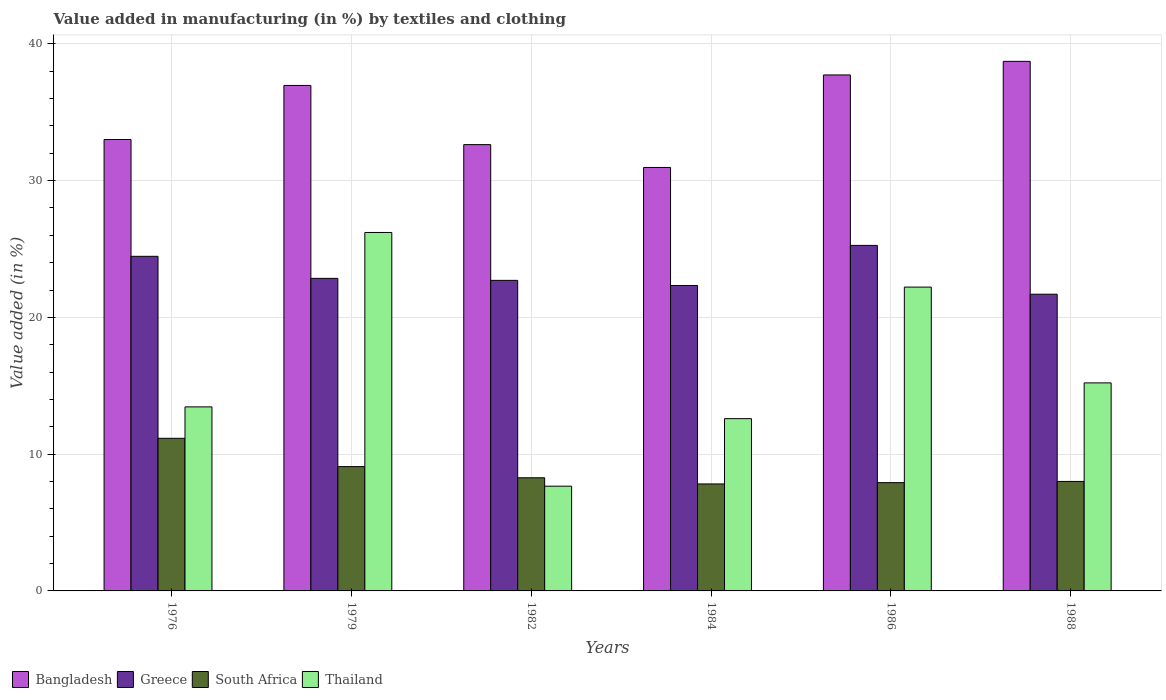How many different coloured bars are there?
Make the answer very short. 4. How many bars are there on the 6th tick from the right?
Ensure brevity in your answer.  4. What is the label of the 2nd group of bars from the left?
Offer a very short reply. 1979. What is the percentage of value added in manufacturing by textiles and clothing in South Africa in 1986?
Your answer should be compact. 7.92. Across all years, what is the maximum percentage of value added in manufacturing by textiles and clothing in Bangladesh?
Make the answer very short. 38.72. Across all years, what is the minimum percentage of value added in manufacturing by textiles and clothing in South Africa?
Make the answer very short. 7.82. In which year was the percentage of value added in manufacturing by textiles and clothing in Bangladesh maximum?
Keep it short and to the point. 1988. What is the total percentage of value added in manufacturing by textiles and clothing in Bangladesh in the graph?
Your response must be concise. 209.99. What is the difference between the percentage of value added in manufacturing by textiles and clothing in Thailand in 1984 and that in 1988?
Make the answer very short. -2.61. What is the difference between the percentage of value added in manufacturing by textiles and clothing in Bangladesh in 1986 and the percentage of value added in manufacturing by textiles and clothing in South Africa in 1984?
Offer a very short reply. 29.9. What is the average percentage of value added in manufacturing by textiles and clothing in Thailand per year?
Offer a very short reply. 16.22. In the year 1988, what is the difference between the percentage of value added in manufacturing by textiles and clothing in Bangladesh and percentage of value added in manufacturing by textiles and clothing in Greece?
Give a very brief answer. 17.02. In how many years, is the percentage of value added in manufacturing by textiles and clothing in Thailand greater than 36 %?
Make the answer very short. 0. What is the ratio of the percentage of value added in manufacturing by textiles and clothing in South Africa in 1986 to that in 1988?
Provide a short and direct response. 0.99. Is the percentage of value added in manufacturing by textiles and clothing in Bangladesh in 1982 less than that in 1986?
Offer a very short reply. Yes. What is the difference between the highest and the second highest percentage of value added in manufacturing by textiles and clothing in Greece?
Your answer should be compact. 0.8. What is the difference between the highest and the lowest percentage of value added in manufacturing by textiles and clothing in Greece?
Your response must be concise. 3.57. What does the 4th bar from the left in 1979 represents?
Keep it short and to the point. Thailand. What does the 2nd bar from the right in 1982 represents?
Your answer should be very brief. South Africa. Is it the case that in every year, the sum of the percentage of value added in manufacturing by textiles and clothing in Thailand and percentage of value added in manufacturing by textiles and clothing in Greece is greater than the percentage of value added in manufacturing by textiles and clothing in Bangladesh?
Provide a short and direct response. No. How many bars are there?
Ensure brevity in your answer.  24. What is the difference between two consecutive major ticks on the Y-axis?
Offer a terse response. 10. Are the values on the major ticks of Y-axis written in scientific E-notation?
Your answer should be very brief. No. Does the graph contain grids?
Your answer should be compact. Yes. Where does the legend appear in the graph?
Provide a succinct answer. Bottom left. How are the legend labels stacked?
Give a very brief answer. Horizontal. What is the title of the graph?
Provide a succinct answer. Value added in manufacturing (in %) by textiles and clothing. Does "Yemen, Rep." appear as one of the legend labels in the graph?
Your answer should be very brief. No. What is the label or title of the Y-axis?
Your answer should be compact. Value added (in %). What is the Value added (in %) in Bangladesh in 1976?
Provide a short and direct response. 33. What is the Value added (in %) of Greece in 1976?
Offer a terse response. 24.46. What is the Value added (in %) of South Africa in 1976?
Provide a succinct answer. 11.16. What is the Value added (in %) in Thailand in 1976?
Give a very brief answer. 13.46. What is the Value added (in %) of Bangladesh in 1979?
Keep it short and to the point. 36.96. What is the Value added (in %) of Greece in 1979?
Offer a very short reply. 22.85. What is the Value added (in %) of South Africa in 1979?
Ensure brevity in your answer.  9.09. What is the Value added (in %) in Thailand in 1979?
Offer a very short reply. 26.21. What is the Value added (in %) of Bangladesh in 1982?
Keep it short and to the point. 32.63. What is the Value added (in %) of Greece in 1982?
Provide a short and direct response. 22.71. What is the Value added (in %) in South Africa in 1982?
Provide a succinct answer. 8.27. What is the Value added (in %) of Thailand in 1982?
Provide a short and direct response. 7.66. What is the Value added (in %) of Bangladesh in 1984?
Offer a terse response. 30.96. What is the Value added (in %) of Greece in 1984?
Provide a short and direct response. 22.33. What is the Value added (in %) in South Africa in 1984?
Ensure brevity in your answer.  7.82. What is the Value added (in %) in Thailand in 1984?
Give a very brief answer. 12.6. What is the Value added (in %) of Bangladesh in 1986?
Provide a succinct answer. 37.72. What is the Value added (in %) of Greece in 1986?
Ensure brevity in your answer.  25.26. What is the Value added (in %) of South Africa in 1986?
Your response must be concise. 7.92. What is the Value added (in %) of Thailand in 1986?
Your response must be concise. 22.21. What is the Value added (in %) of Bangladesh in 1988?
Provide a short and direct response. 38.72. What is the Value added (in %) in Greece in 1988?
Ensure brevity in your answer.  21.69. What is the Value added (in %) in South Africa in 1988?
Provide a succinct answer. 8.01. What is the Value added (in %) in Thailand in 1988?
Give a very brief answer. 15.21. Across all years, what is the maximum Value added (in %) in Bangladesh?
Your response must be concise. 38.72. Across all years, what is the maximum Value added (in %) of Greece?
Your answer should be compact. 25.26. Across all years, what is the maximum Value added (in %) of South Africa?
Provide a succinct answer. 11.16. Across all years, what is the maximum Value added (in %) in Thailand?
Make the answer very short. 26.21. Across all years, what is the minimum Value added (in %) in Bangladesh?
Provide a short and direct response. 30.96. Across all years, what is the minimum Value added (in %) in Greece?
Offer a terse response. 21.69. Across all years, what is the minimum Value added (in %) of South Africa?
Make the answer very short. 7.82. Across all years, what is the minimum Value added (in %) of Thailand?
Your answer should be compact. 7.66. What is the total Value added (in %) of Bangladesh in the graph?
Offer a very short reply. 209.99. What is the total Value added (in %) in Greece in the graph?
Make the answer very short. 139.31. What is the total Value added (in %) in South Africa in the graph?
Your answer should be compact. 52.26. What is the total Value added (in %) of Thailand in the graph?
Offer a very short reply. 97.34. What is the difference between the Value added (in %) of Bangladesh in 1976 and that in 1979?
Ensure brevity in your answer.  -3.95. What is the difference between the Value added (in %) of Greece in 1976 and that in 1979?
Keep it short and to the point. 1.61. What is the difference between the Value added (in %) in South Africa in 1976 and that in 1979?
Ensure brevity in your answer.  2.07. What is the difference between the Value added (in %) in Thailand in 1976 and that in 1979?
Offer a terse response. -12.75. What is the difference between the Value added (in %) of Bangladesh in 1976 and that in 1982?
Your answer should be compact. 0.37. What is the difference between the Value added (in %) in Greece in 1976 and that in 1982?
Offer a very short reply. 1.76. What is the difference between the Value added (in %) in South Africa in 1976 and that in 1982?
Your answer should be very brief. 2.89. What is the difference between the Value added (in %) of Thailand in 1976 and that in 1982?
Provide a succinct answer. 5.8. What is the difference between the Value added (in %) in Bangladesh in 1976 and that in 1984?
Give a very brief answer. 2.04. What is the difference between the Value added (in %) of Greece in 1976 and that in 1984?
Your answer should be compact. 2.13. What is the difference between the Value added (in %) of South Africa in 1976 and that in 1984?
Give a very brief answer. 3.34. What is the difference between the Value added (in %) of Thailand in 1976 and that in 1984?
Offer a terse response. 0.86. What is the difference between the Value added (in %) in Bangladesh in 1976 and that in 1986?
Give a very brief answer. -4.72. What is the difference between the Value added (in %) in Greece in 1976 and that in 1986?
Provide a short and direct response. -0.8. What is the difference between the Value added (in %) of South Africa in 1976 and that in 1986?
Offer a very short reply. 3.24. What is the difference between the Value added (in %) in Thailand in 1976 and that in 1986?
Offer a terse response. -8.76. What is the difference between the Value added (in %) in Bangladesh in 1976 and that in 1988?
Your response must be concise. -5.71. What is the difference between the Value added (in %) of Greece in 1976 and that in 1988?
Give a very brief answer. 2.77. What is the difference between the Value added (in %) in South Africa in 1976 and that in 1988?
Ensure brevity in your answer.  3.15. What is the difference between the Value added (in %) of Thailand in 1976 and that in 1988?
Provide a succinct answer. -1.75. What is the difference between the Value added (in %) of Bangladesh in 1979 and that in 1982?
Your answer should be compact. 4.33. What is the difference between the Value added (in %) in Greece in 1979 and that in 1982?
Your answer should be very brief. 0.15. What is the difference between the Value added (in %) of South Africa in 1979 and that in 1982?
Your answer should be compact. 0.82. What is the difference between the Value added (in %) in Thailand in 1979 and that in 1982?
Keep it short and to the point. 18.55. What is the difference between the Value added (in %) of Bangladesh in 1979 and that in 1984?
Keep it short and to the point. 6. What is the difference between the Value added (in %) in Greece in 1979 and that in 1984?
Your answer should be compact. 0.52. What is the difference between the Value added (in %) of South Africa in 1979 and that in 1984?
Offer a very short reply. 1.27. What is the difference between the Value added (in %) in Thailand in 1979 and that in 1984?
Ensure brevity in your answer.  13.61. What is the difference between the Value added (in %) in Bangladesh in 1979 and that in 1986?
Provide a succinct answer. -0.77. What is the difference between the Value added (in %) in Greece in 1979 and that in 1986?
Keep it short and to the point. -2.41. What is the difference between the Value added (in %) in South Africa in 1979 and that in 1986?
Offer a terse response. 1.17. What is the difference between the Value added (in %) of Thailand in 1979 and that in 1986?
Ensure brevity in your answer.  3.99. What is the difference between the Value added (in %) in Bangladesh in 1979 and that in 1988?
Offer a very short reply. -1.76. What is the difference between the Value added (in %) of Greece in 1979 and that in 1988?
Your answer should be very brief. 1.16. What is the difference between the Value added (in %) in South Africa in 1979 and that in 1988?
Your response must be concise. 1.08. What is the difference between the Value added (in %) of Thailand in 1979 and that in 1988?
Offer a terse response. 11. What is the difference between the Value added (in %) of Bangladesh in 1982 and that in 1984?
Give a very brief answer. 1.67. What is the difference between the Value added (in %) of Greece in 1982 and that in 1984?
Your answer should be very brief. 0.37. What is the difference between the Value added (in %) in South Africa in 1982 and that in 1984?
Give a very brief answer. 0.45. What is the difference between the Value added (in %) in Thailand in 1982 and that in 1984?
Your answer should be very brief. -4.94. What is the difference between the Value added (in %) in Bangladesh in 1982 and that in 1986?
Give a very brief answer. -5.09. What is the difference between the Value added (in %) of Greece in 1982 and that in 1986?
Provide a short and direct response. -2.56. What is the difference between the Value added (in %) in South Africa in 1982 and that in 1986?
Your answer should be very brief. 0.36. What is the difference between the Value added (in %) in Thailand in 1982 and that in 1986?
Make the answer very short. -14.56. What is the difference between the Value added (in %) of Bangladesh in 1982 and that in 1988?
Offer a terse response. -6.09. What is the difference between the Value added (in %) of Greece in 1982 and that in 1988?
Give a very brief answer. 1.01. What is the difference between the Value added (in %) of South Africa in 1982 and that in 1988?
Your response must be concise. 0.27. What is the difference between the Value added (in %) in Thailand in 1982 and that in 1988?
Your answer should be very brief. -7.55. What is the difference between the Value added (in %) of Bangladesh in 1984 and that in 1986?
Offer a terse response. -6.76. What is the difference between the Value added (in %) of Greece in 1984 and that in 1986?
Offer a terse response. -2.93. What is the difference between the Value added (in %) of South Africa in 1984 and that in 1986?
Keep it short and to the point. -0.09. What is the difference between the Value added (in %) in Thailand in 1984 and that in 1986?
Offer a terse response. -9.62. What is the difference between the Value added (in %) in Bangladesh in 1984 and that in 1988?
Keep it short and to the point. -7.76. What is the difference between the Value added (in %) in Greece in 1984 and that in 1988?
Your answer should be very brief. 0.64. What is the difference between the Value added (in %) in South Africa in 1984 and that in 1988?
Provide a succinct answer. -0.18. What is the difference between the Value added (in %) of Thailand in 1984 and that in 1988?
Your response must be concise. -2.61. What is the difference between the Value added (in %) in Bangladesh in 1986 and that in 1988?
Your response must be concise. -0.99. What is the difference between the Value added (in %) in Greece in 1986 and that in 1988?
Provide a succinct answer. 3.57. What is the difference between the Value added (in %) of South Africa in 1986 and that in 1988?
Your answer should be very brief. -0.09. What is the difference between the Value added (in %) of Thailand in 1986 and that in 1988?
Your response must be concise. 7. What is the difference between the Value added (in %) in Bangladesh in 1976 and the Value added (in %) in Greece in 1979?
Give a very brief answer. 10.15. What is the difference between the Value added (in %) in Bangladesh in 1976 and the Value added (in %) in South Africa in 1979?
Your answer should be compact. 23.91. What is the difference between the Value added (in %) in Bangladesh in 1976 and the Value added (in %) in Thailand in 1979?
Keep it short and to the point. 6.8. What is the difference between the Value added (in %) of Greece in 1976 and the Value added (in %) of South Africa in 1979?
Your answer should be compact. 15.38. What is the difference between the Value added (in %) in Greece in 1976 and the Value added (in %) in Thailand in 1979?
Provide a short and direct response. -1.74. What is the difference between the Value added (in %) in South Africa in 1976 and the Value added (in %) in Thailand in 1979?
Ensure brevity in your answer.  -15.05. What is the difference between the Value added (in %) in Bangladesh in 1976 and the Value added (in %) in Greece in 1982?
Make the answer very short. 10.3. What is the difference between the Value added (in %) in Bangladesh in 1976 and the Value added (in %) in South Africa in 1982?
Provide a short and direct response. 24.73. What is the difference between the Value added (in %) of Bangladesh in 1976 and the Value added (in %) of Thailand in 1982?
Your answer should be very brief. 25.35. What is the difference between the Value added (in %) in Greece in 1976 and the Value added (in %) in South Africa in 1982?
Offer a terse response. 16.19. What is the difference between the Value added (in %) of Greece in 1976 and the Value added (in %) of Thailand in 1982?
Your response must be concise. 16.81. What is the difference between the Value added (in %) in South Africa in 1976 and the Value added (in %) in Thailand in 1982?
Offer a very short reply. 3.5. What is the difference between the Value added (in %) in Bangladesh in 1976 and the Value added (in %) in Greece in 1984?
Make the answer very short. 10.67. What is the difference between the Value added (in %) in Bangladesh in 1976 and the Value added (in %) in South Africa in 1984?
Your answer should be very brief. 25.18. What is the difference between the Value added (in %) of Bangladesh in 1976 and the Value added (in %) of Thailand in 1984?
Keep it short and to the point. 20.41. What is the difference between the Value added (in %) in Greece in 1976 and the Value added (in %) in South Africa in 1984?
Provide a succinct answer. 16.64. What is the difference between the Value added (in %) in Greece in 1976 and the Value added (in %) in Thailand in 1984?
Offer a very short reply. 11.87. What is the difference between the Value added (in %) of South Africa in 1976 and the Value added (in %) of Thailand in 1984?
Offer a terse response. -1.44. What is the difference between the Value added (in %) of Bangladesh in 1976 and the Value added (in %) of Greece in 1986?
Ensure brevity in your answer.  7.74. What is the difference between the Value added (in %) of Bangladesh in 1976 and the Value added (in %) of South Africa in 1986?
Give a very brief answer. 25.09. What is the difference between the Value added (in %) of Bangladesh in 1976 and the Value added (in %) of Thailand in 1986?
Your response must be concise. 10.79. What is the difference between the Value added (in %) in Greece in 1976 and the Value added (in %) in South Africa in 1986?
Keep it short and to the point. 16.55. What is the difference between the Value added (in %) of Greece in 1976 and the Value added (in %) of Thailand in 1986?
Make the answer very short. 2.25. What is the difference between the Value added (in %) in South Africa in 1976 and the Value added (in %) in Thailand in 1986?
Make the answer very short. -11.05. What is the difference between the Value added (in %) in Bangladesh in 1976 and the Value added (in %) in Greece in 1988?
Provide a succinct answer. 11.31. What is the difference between the Value added (in %) of Bangladesh in 1976 and the Value added (in %) of South Africa in 1988?
Offer a terse response. 25. What is the difference between the Value added (in %) in Bangladesh in 1976 and the Value added (in %) in Thailand in 1988?
Provide a short and direct response. 17.79. What is the difference between the Value added (in %) of Greece in 1976 and the Value added (in %) of South Africa in 1988?
Offer a very short reply. 16.46. What is the difference between the Value added (in %) of Greece in 1976 and the Value added (in %) of Thailand in 1988?
Provide a short and direct response. 9.25. What is the difference between the Value added (in %) of South Africa in 1976 and the Value added (in %) of Thailand in 1988?
Offer a terse response. -4.05. What is the difference between the Value added (in %) of Bangladesh in 1979 and the Value added (in %) of Greece in 1982?
Make the answer very short. 14.25. What is the difference between the Value added (in %) of Bangladesh in 1979 and the Value added (in %) of South Africa in 1982?
Your answer should be very brief. 28.68. What is the difference between the Value added (in %) in Bangladesh in 1979 and the Value added (in %) in Thailand in 1982?
Offer a very short reply. 29.3. What is the difference between the Value added (in %) in Greece in 1979 and the Value added (in %) in South Africa in 1982?
Offer a terse response. 14.58. What is the difference between the Value added (in %) in Greece in 1979 and the Value added (in %) in Thailand in 1982?
Ensure brevity in your answer.  15.19. What is the difference between the Value added (in %) of South Africa in 1979 and the Value added (in %) of Thailand in 1982?
Provide a short and direct response. 1.43. What is the difference between the Value added (in %) of Bangladesh in 1979 and the Value added (in %) of Greece in 1984?
Give a very brief answer. 14.62. What is the difference between the Value added (in %) of Bangladesh in 1979 and the Value added (in %) of South Africa in 1984?
Keep it short and to the point. 29.13. What is the difference between the Value added (in %) in Bangladesh in 1979 and the Value added (in %) in Thailand in 1984?
Provide a succinct answer. 24.36. What is the difference between the Value added (in %) of Greece in 1979 and the Value added (in %) of South Africa in 1984?
Your answer should be very brief. 15.03. What is the difference between the Value added (in %) of Greece in 1979 and the Value added (in %) of Thailand in 1984?
Offer a terse response. 10.26. What is the difference between the Value added (in %) in South Africa in 1979 and the Value added (in %) in Thailand in 1984?
Keep it short and to the point. -3.51. What is the difference between the Value added (in %) in Bangladesh in 1979 and the Value added (in %) in Greece in 1986?
Offer a terse response. 11.69. What is the difference between the Value added (in %) of Bangladesh in 1979 and the Value added (in %) of South Africa in 1986?
Your response must be concise. 29.04. What is the difference between the Value added (in %) of Bangladesh in 1979 and the Value added (in %) of Thailand in 1986?
Offer a terse response. 14.74. What is the difference between the Value added (in %) of Greece in 1979 and the Value added (in %) of South Africa in 1986?
Your answer should be very brief. 14.94. What is the difference between the Value added (in %) in Greece in 1979 and the Value added (in %) in Thailand in 1986?
Provide a succinct answer. 0.64. What is the difference between the Value added (in %) in South Africa in 1979 and the Value added (in %) in Thailand in 1986?
Your answer should be compact. -13.12. What is the difference between the Value added (in %) in Bangladesh in 1979 and the Value added (in %) in Greece in 1988?
Your response must be concise. 15.26. What is the difference between the Value added (in %) in Bangladesh in 1979 and the Value added (in %) in South Africa in 1988?
Ensure brevity in your answer.  28.95. What is the difference between the Value added (in %) of Bangladesh in 1979 and the Value added (in %) of Thailand in 1988?
Give a very brief answer. 21.75. What is the difference between the Value added (in %) in Greece in 1979 and the Value added (in %) in South Africa in 1988?
Your response must be concise. 14.85. What is the difference between the Value added (in %) in Greece in 1979 and the Value added (in %) in Thailand in 1988?
Offer a very short reply. 7.64. What is the difference between the Value added (in %) of South Africa in 1979 and the Value added (in %) of Thailand in 1988?
Your response must be concise. -6.12. What is the difference between the Value added (in %) of Bangladesh in 1982 and the Value added (in %) of Greece in 1984?
Keep it short and to the point. 10.3. What is the difference between the Value added (in %) in Bangladesh in 1982 and the Value added (in %) in South Africa in 1984?
Provide a short and direct response. 24.81. What is the difference between the Value added (in %) in Bangladesh in 1982 and the Value added (in %) in Thailand in 1984?
Offer a terse response. 20.03. What is the difference between the Value added (in %) in Greece in 1982 and the Value added (in %) in South Africa in 1984?
Provide a short and direct response. 14.88. What is the difference between the Value added (in %) in Greece in 1982 and the Value added (in %) in Thailand in 1984?
Offer a very short reply. 10.11. What is the difference between the Value added (in %) of South Africa in 1982 and the Value added (in %) of Thailand in 1984?
Provide a succinct answer. -4.32. What is the difference between the Value added (in %) of Bangladesh in 1982 and the Value added (in %) of Greece in 1986?
Make the answer very short. 7.37. What is the difference between the Value added (in %) in Bangladesh in 1982 and the Value added (in %) in South Africa in 1986?
Provide a succinct answer. 24.71. What is the difference between the Value added (in %) of Bangladesh in 1982 and the Value added (in %) of Thailand in 1986?
Give a very brief answer. 10.42. What is the difference between the Value added (in %) of Greece in 1982 and the Value added (in %) of South Africa in 1986?
Provide a short and direct response. 14.79. What is the difference between the Value added (in %) in Greece in 1982 and the Value added (in %) in Thailand in 1986?
Provide a succinct answer. 0.49. What is the difference between the Value added (in %) of South Africa in 1982 and the Value added (in %) of Thailand in 1986?
Your answer should be very brief. -13.94. What is the difference between the Value added (in %) of Bangladesh in 1982 and the Value added (in %) of Greece in 1988?
Offer a very short reply. 10.94. What is the difference between the Value added (in %) of Bangladesh in 1982 and the Value added (in %) of South Africa in 1988?
Offer a terse response. 24.63. What is the difference between the Value added (in %) in Bangladesh in 1982 and the Value added (in %) in Thailand in 1988?
Provide a succinct answer. 17.42. What is the difference between the Value added (in %) of Greece in 1982 and the Value added (in %) of South Africa in 1988?
Provide a succinct answer. 14.7. What is the difference between the Value added (in %) in Greece in 1982 and the Value added (in %) in Thailand in 1988?
Ensure brevity in your answer.  7.5. What is the difference between the Value added (in %) in South Africa in 1982 and the Value added (in %) in Thailand in 1988?
Ensure brevity in your answer.  -6.94. What is the difference between the Value added (in %) in Bangladesh in 1984 and the Value added (in %) in Greece in 1986?
Your response must be concise. 5.7. What is the difference between the Value added (in %) of Bangladesh in 1984 and the Value added (in %) of South Africa in 1986?
Your answer should be compact. 23.04. What is the difference between the Value added (in %) of Bangladesh in 1984 and the Value added (in %) of Thailand in 1986?
Offer a terse response. 8.75. What is the difference between the Value added (in %) in Greece in 1984 and the Value added (in %) in South Africa in 1986?
Make the answer very short. 14.42. What is the difference between the Value added (in %) in Greece in 1984 and the Value added (in %) in Thailand in 1986?
Offer a terse response. 0.12. What is the difference between the Value added (in %) of South Africa in 1984 and the Value added (in %) of Thailand in 1986?
Your answer should be compact. -14.39. What is the difference between the Value added (in %) in Bangladesh in 1984 and the Value added (in %) in Greece in 1988?
Make the answer very short. 9.27. What is the difference between the Value added (in %) in Bangladesh in 1984 and the Value added (in %) in South Africa in 1988?
Ensure brevity in your answer.  22.96. What is the difference between the Value added (in %) in Bangladesh in 1984 and the Value added (in %) in Thailand in 1988?
Your answer should be very brief. 15.75. What is the difference between the Value added (in %) of Greece in 1984 and the Value added (in %) of South Africa in 1988?
Give a very brief answer. 14.33. What is the difference between the Value added (in %) in Greece in 1984 and the Value added (in %) in Thailand in 1988?
Ensure brevity in your answer.  7.12. What is the difference between the Value added (in %) in South Africa in 1984 and the Value added (in %) in Thailand in 1988?
Your answer should be compact. -7.39. What is the difference between the Value added (in %) of Bangladesh in 1986 and the Value added (in %) of Greece in 1988?
Make the answer very short. 16.03. What is the difference between the Value added (in %) in Bangladesh in 1986 and the Value added (in %) in South Africa in 1988?
Your response must be concise. 29.72. What is the difference between the Value added (in %) in Bangladesh in 1986 and the Value added (in %) in Thailand in 1988?
Give a very brief answer. 22.51. What is the difference between the Value added (in %) in Greece in 1986 and the Value added (in %) in South Africa in 1988?
Provide a succinct answer. 17.26. What is the difference between the Value added (in %) in Greece in 1986 and the Value added (in %) in Thailand in 1988?
Give a very brief answer. 10.05. What is the difference between the Value added (in %) of South Africa in 1986 and the Value added (in %) of Thailand in 1988?
Make the answer very short. -7.29. What is the average Value added (in %) of Bangladesh per year?
Keep it short and to the point. 35. What is the average Value added (in %) of Greece per year?
Keep it short and to the point. 23.22. What is the average Value added (in %) in South Africa per year?
Offer a terse response. 8.71. What is the average Value added (in %) of Thailand per year?
Ensure brevity in your answer.  16.22. In the year 1976, what is the difference between the Value added (in %) in Bangladesh and Value added (in %) in Greece?
Give a very brief answer. 8.54. In the year 1976, what is the difference between the Value added (in %) of Bangladesh and Value added (in %) of South Africa?
Offer a very short reply. 21.84. In the year 1976, what is the difference between the Value added (in %) in Bangladesh and Value added (in %) in Thailand?
Provide a short and direct response. 19.55. In the year 1976, what is the difference between the Value added (in %) of Greece and Value added (in %) of South Africa?
Keep it short and to the point. 13.31. In the year 1976, what is the difference between the Value added (in %) in Greece and Value added (in %) in Thailand?
Ensure brevity in your answer.  11.01. In the year 1976, what is the difference between the Value added (in %) in South Africa and Value added (in %) in Thailand?
Keep it short and to the point. -2.3. In the year 1979, what is the difference between the Value added (in %) in Bangladesh and Value added (in %) in Greece?
Provide a short and direct response. 14.11. In the year 1979, what is the difference between the Value added (in %) in Bangladesh and Value added (in %) in South Africa?
Ensure brevity in your answer.  27.87. In the year 1979, what is the difference between the Value added (in %) of Bangladesh and Value added (in %) of Thailand?
Provide a short and direct response. 10.75. In the year 1979, what is the difference between the Value added (in %) in Greece and Value added (in %) in South Africa?
Keep it short and to the point. 13.76. In the year 1979, what is the difference between the Value added (in %) of Greece and Value added (in %) of Thailand?
Your answer should be compact. -3.36. In the year 1979, what is the difference between the Value added (in %) of South Africa and Value added (in %) of Thailand?
Make the answer very short. -17.12. In the year 1982, what is the difference between the Value added (in %) of Bangladesh and Value added (in %) of Greece?
Provide a succinct answer. 9.92. In the year 1982, what is the difference between the Value added (in %) of Bangladesh and Value added (in %) of South Africa?
Make the answer very short. 24.36. In the year 1982, what is the difference between the Value added (in %) in Bangladesh and Value added (in %) in Thailand?
Your answer should be compact. 24.97. In the year 1982, what is the difference between the Value added (in %) of Greece and Value added (in %) of South Africa?
Provide a succinct answer. 14.43. In the year 1982, what is the difference between the Value added (in %) of Greece and Value added (in %) of Thailand?
Your response must be concise. 15.05. In the year 1982, what is the difference between the Value added (in %) in South Africa and Value added (in %) in Thailand?
Your answer should be very brief. 0.61. In the year 1984, what is the difference between the Value added (in %) of Bangladesh and Value added (in %) of Greece?
Give a very brief answer. 8.63. In the year 1984, what is the difference between the Value added (in %) of Bangladesh and Value added (in %) of South Africa?
Your answer should be compact. 23.14. In the year 1984, what is the difference between the Value added (in %) in Bangladesh and Value added (in %) in Thailand?
Provide a short and direct response. 18.37. In the year 1984, what is the difference between the Value added (in %) in Greece and Value added (in %) in South Africa?
Provide a short and direct response. 14.51. In the year 1984, what is the difference between the Value added (in %) of Greece and Value added (in %) of Thailand?
Keep it short and to the point. 9.74. In the year 1984, what is the difference between the Value added (in %) in South Africa and Value added (in %) in Thailand?
Your answer should be compact. -4.77. In the year 1986, what is the difference between the Value added (in %) of Bangladesh and Value added (in %) of Greece?
Your response must be concise. 12.46. In the year 1986, what is the difference between the Value added (in %) in Bangladesh and Value added (in %) in South Africa?
Make the answer very short. 29.81. In the year 1986, what is the difference between the Value added (in %) of Bangladesh and Value added (in %) of Thailand?
Your response must be concise. 15.51. In the year 1986, what is the difference between the Value added (in %) in Greece and Value added (in %) in South Africa?
Offer a terse response. 17.35. In the year 1986, what is the difference between the Value added (in %) in Greece and Value added (in %) in Thailand?
Provide a succinct answer. 3.05. In the year 1986, what is the difference between the Value added (in %) in South Africa and Value added (in %) in Thailand?
Keep it short and to the point. -14.3. In the year 1988, what is the difference between the Value added (in %) of Bangladesh and Value added (in %) of Greece?
Offer a very short reply. 17.02. In the year 1988, what is the difference between the Value added (in %) of Bangladesh and Value added (in %) of South Africa?
Make the answer very short. 30.71. In the year 1988, what is the difference between the Value added (in %) of Bangladesh and Value added (in %) of Thailand?
Your answer should be compact. 23.51. In the year 1988, what is the difference between the Value added (in %) of Greece and Value added (in %) of South Africa?
Your answer should be very brief. 13.69. In the year 1988, what is the difference between the Value added (in %) of Greece and Value added (in %) of Thailand?
Offer a very short reply. 6.48. In the year 1988, what is the difference between the Value added (in %) in South Africa and Value added (in %) in Thailand?
Ensure brevity in your answer.  -7.21. What is the ratio of the Value added (in %) of Bangladesh in 1976 to that in 1979?
Offer a very short reply. 0.89. What is the ratio of the Value added (in %) in Greece in 1976 to that in 1979?
Ensure brevity in your answer.  1.07. What is the ratio of the Value added (in %) of South Africa in 1976 to that in 1979?
Offer a terse response. 1.23. What is the ratio of the Value added (in %) of Thailand in 1976 to that in 1979?
Make the answer very short. 0.51. What is the ratio of the Value added (in %) of Bangladesh in 1976 to that in 1982?
Ensure brevity in your answer.  1.01. What is the ratio of the Value added (in %) of Greece in 1976 to that in 1982?
Give a very brief answer. 1.08. What is the ratio of the Value added (in %) in South Africa in 1976 to that in 1982?
Keep it short and to the point. 1.35. What is the ratio of the Value added (in %) in Thailand in 1976 to that in 1982?
Keep it short and to the point. 1.76. What is the ratio of the Value added (in %) in Bangladesh in 1976 to that in 1984?
Give a very brief answer. 1.07. What is the ratio of the Value added (in %) in Greece in 1976 to that in 1984?
Keep it short and to the point. 1.1. What is the ratio of the Value added (in %) in South Africa in 1976 to that in 1984?
Provide a succinct answer. 1.43. What is the ratio of the Value added (in %) of Thailand in 1976 to that in 1984?
Ensure brevity in your answer.  1.07. What is the ratio of the Value added (in %) of Bangladesh in 1976 to that in 1986?
Provide a succinct answer. 0.87. What is the ratio of the Value added (in %) of Greece in 1976 to that in 1986?
Make the answer very short. 0.97. What is the ratio of the Value added (in %) of South Africa in 1976 to that in 1986?
Offer a terse response. 1.41. What is the ratio of the Value added (in %) in Thailand in 1976 to that in 1986?
Provide a succinct answer. 0.61. What is the ratio of the Value added (in %) of Bangladesh in 1976 to that in 1988?
Provide a short and direct response. 0.85. What is the ratio of the Value added (in %) in Greece in 1976 to that in 1988?
Offer a very short reply. 1.13. What is the ratio of the Value added (in %) in South Africa in 1976 to that in 1988?
Your answer should be very brief. 1.39. What is the ratio of the Value added (in %) of Thailand in 1976 to that in 1988?
Ensure brevity in your answer.  0.88. What is the ratio of the Value added (in %) in Bangladesh in 1979 to that in 1982?
Offer a terse response. 1.13. What is the ratio of the Value added (in %) in Greece in 1979 to that in 1982?
Your answer should be compact. 1.01. What is the ratio of the Value added (in %) of South Africa in 1979 to that in 1982?
Offer a terse response. 1.1. What is the ratio of the Value added (in %) of Thailand in 1979 to that in 1982?
Ensure brevity in your answer.  3.42. What is the ratio of the Value added (in %) in Bangladesh in 1979 to that in 1984?
Ensure brevity in your answer.  1.19. What is the ratio of the Value added (in %) of Greece in 1979 to that in 1984?
Provide a succinct answer. 1.02. What is the ratio of the Value added (in %) of South Africa in 1979 to that in 1984?
Keep it short and to the point. 1.16. What is the ratio of the Value added (in %) of Thailand in 1979 to that in 1984?
Provide a succinct answer. 2.08. What is the ratio of the Value added (in %) of Bangladesh in 1979 to that in 1986?
Ensure brevity in your answer.  0.98. What is the ratio of the Value added (in %) of Greece in 1979 to that in 1986?
Provide a succinct answer. 0.9. What is the ratio of the Value added (in %) of South Africa in 1979 to that in 1986?
Ensure brevity in your answer.  1.15. What is the ratio of the Value added (in %) of Thailand in 1979 to that in 1986?
Your answer should be very brief. 1.18. What is the ratio of the Value added (in %) in Bangladesh in 1979 to that in 1988?
Your answer should be very brief. 0.95. What is the ratio of the Value added (in %) in Greece in 1979 to that in 1988?
Provide a short and direct response. 1.05. What is the ratio of the Value added (in %) in South Africa in 1979 to that in 1988?
Offer a very short reply. 1.14. What is the ratio of the Value added (in %) of Thailand in 1979 to that in 1988?
Provide a succinct answer. 1.72. What is the ratio of the Value added (in %) in Bangladesh in 1982 to that in 1984?
Your answer should be compact. 1.05. What is the ratio of the Value added (in %) in Greece in 1982 to that in 1984?
Keep it short and to the point. 1.02. What is the ratio of the Value added (in %) of South Africa in 1982 to that in 1984?
Make the answer very short. 1.06. What is the ratio of the Value added (in %) in Thailand in 1982 to that in 1984?
Provide a succinct answer. 0.61. What is the ratio of the Value added (in %) in Bangladesh in 1982 to that in 1986?
Your response must be concise. 0.86. What is the ratio of the Value added (in %) of Greece in 1982 to that in 1986?
Provide a succinct answer. 0.9. What is the ratio of the Value added (in %) in South Africa in 1982 to that in 1986?
Provide a short and direct response. 1.04. What is the ratio of the Value added (in %) of Thailand in 1982 to that in 1986?
Keep it short and to the point. 0.34. What is the ratio of the Value added (in %) in Bangladesh in 1982 to that in 1988?
Keep it short and to the point. 0.84. What is the ratio of the Value added (in %) in Greece in 1982 to that in 1988?
Give a very brief answer. 1.05. What is the ratio of the Value added (in %) of South Africa in 1982 to that in 1988?
Provide a short and direct response. 1.03. What is the ratio of the Value added (in %) of Thailand in 1982 to that in 1988?
Give a very brief answer. 0.5. What is the ratio of the Value added (in %) of Bangladesh in 1984 to that in 1986?
Make the answer very short. 0.82. What is the ratio of the Value added (in %) of Greece in 1984 to that in 1986?
Provide a succinct answer. 0.88. What is the ratio of the Value added (in %) of Thailand in 1984 to that in 1986?
Your answer should be compact. 0.57. What is the ratio of the Value added (in %) of Bangladesh in 1984 to that in 1988?
Give a very brief answer. 0.8. What is the ratio of the Value added (in %) of Greece in 1984 to that in 1988?
Give a very brief answer. 1.03. What is the ratio of the Value added (in %) of South Africa in 1984 to that in 1988?
Provide a succinct answer. 0.98. What is the ratio of the Value added (in %) in Thailand in 1984 to that in 1988?
Make the answer very short. 0.83. What is the ratio of the Value added (in %) of Bangladesh in 1986 to that in 1988?
Your response must be concise. 0.97. What is the ratio of the Value added (in %) in Greece in 1986 to that in 1988?
Provide a succinct answer. 1.16. What is the ratio of the Value added (in %) in South Africa in 1986 to that in 1988?
Make the answer very short. 0.99. What is the ratio of the Value added (in %) of Thailand in 1986 to that in 1988?
Make the answer very short. 1.46. What is the difference between the highest and the second highest Value added (in %) in Bangladesh?
Provide a short and direct response. 0.99. What is the difference between the highest and the second highest Value added (in %) in Greece?
Provide a succinct answer. 0.8. What is the difference between the highest and the second highest Value added (in %) in South Africa?
Offer a terse response. 2.07. What is the difference between the highest and the second highest Value added (in %) in Thailand?
Ensure brevity in your answer.  3.99. What is the difference between the highest and the lowest Value added (in %) in Bangladesh?
Provide a short and direct response. 7.76. What is the difference between the highest and the lowest Value added (in %) in Greece?
Offer a terse response. 3.57. What is the difference between the highest and the lowest Value added (in %) of South Africa?
Your response must be concise. 3.34. What is the difference between the highest and the lowest Value added (in %) of Thailand?
Ensure brevity in your answer.  18.55. 